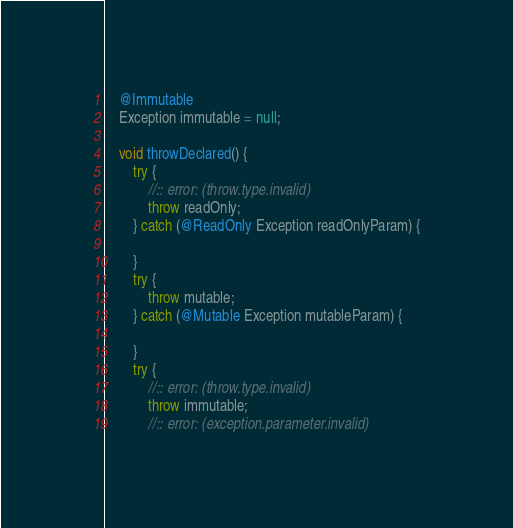<code> <loc_0><loc_0><loc_500><loc_500><_Java_>    @Immutable
    Exception immutable = null;

    void throwDeclared() {
        try {
            //:: error: (throw.type.invalid)
            throw readOnly;
        } catch (@ReadOnly Exception readOnlyParam) {

        }
        try {
            throw mutable;
        } catch (@Mutable Exception mutableParam) {

        }
        try {
            //:: error: (throw.type.invalid)
            throw immutable;
            //:: error: (exception.parameter.invalid)</code> 